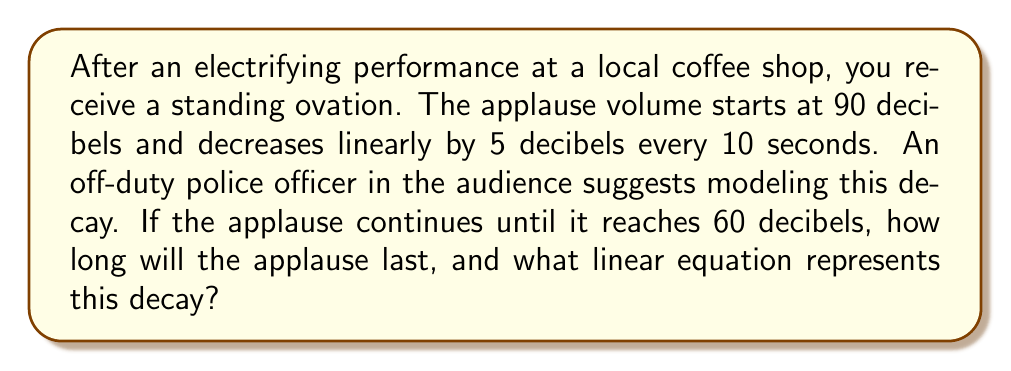Provide a solution to this math problem. Let's approach this step-by-step:

1) First, we need to identify the key information:
   - Initial volume: 90 decibels
   - Decay rate: 5 decibels per 10 seconds
   - Final volume: 60 decibels

2) Let's define our variables:
   $y$ = volume in decibels
   $x$ = time in seconds

3) We can write the general form of a linear equation:
   $y = mx + b$
   where $m$ is the slope (rate of change) and $b$ is the y-intercept (initial value)

4) Calculate the slope:
   $m = \frac{\text{change in y}}{\text{change in x}} = \frac{-5 \text{ decibels}}{10 \text{ seconds}} = -0.5 \text{ decibels/second}$

5) The y-intercept is the initial volume: $b = 90$

6) Therefore, our linear equation is:
   $y = -0.5x + 90$

7) To find how long the applause lasts, we need to solve for $x$ when $y = 60$:
   $60 = -0.5x + 90$
   $-30 = -0.5x$
   $x = 60$ seconds

Thus, the applause will last 60 seconds.
Answer: The linear equation representing the decay of applause volume is $y = -0.5x + 90$, where $y$ is the volume in decibels and $x$ is the time in seconds. The applause will last 60 seconds. 